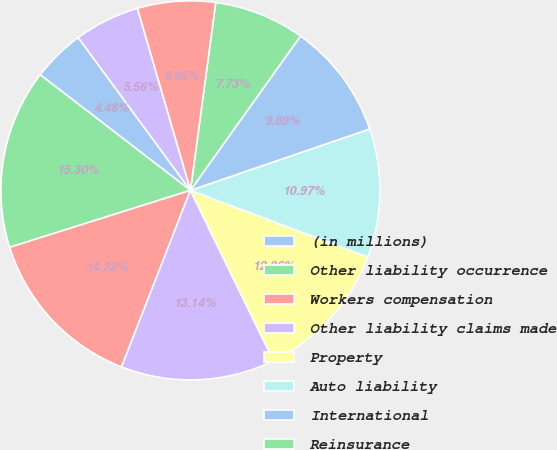Convert chart to OTSL. <chart><loc_0><loc_0><loc_500><loc_500><pie_chart><fcel>(in millions)<fcel>Other liability occurrence<fcel>Workers compensation<fcel>Other liability claims made<fcel>Property<fcel>Auto liability<fcel>International<fcel>Reinsurance<fcel>Medical malpractice<fcel>Products liability<nl><fcel>4.48%<fcel>15.3%<fcel>14.22%<fcel>13.14%<fcel>12.06%<fcel>10.97%<fcel>9.89%<fcel>7.73%<fcel>6.65%<fcel>5.56%<nl></chart> 